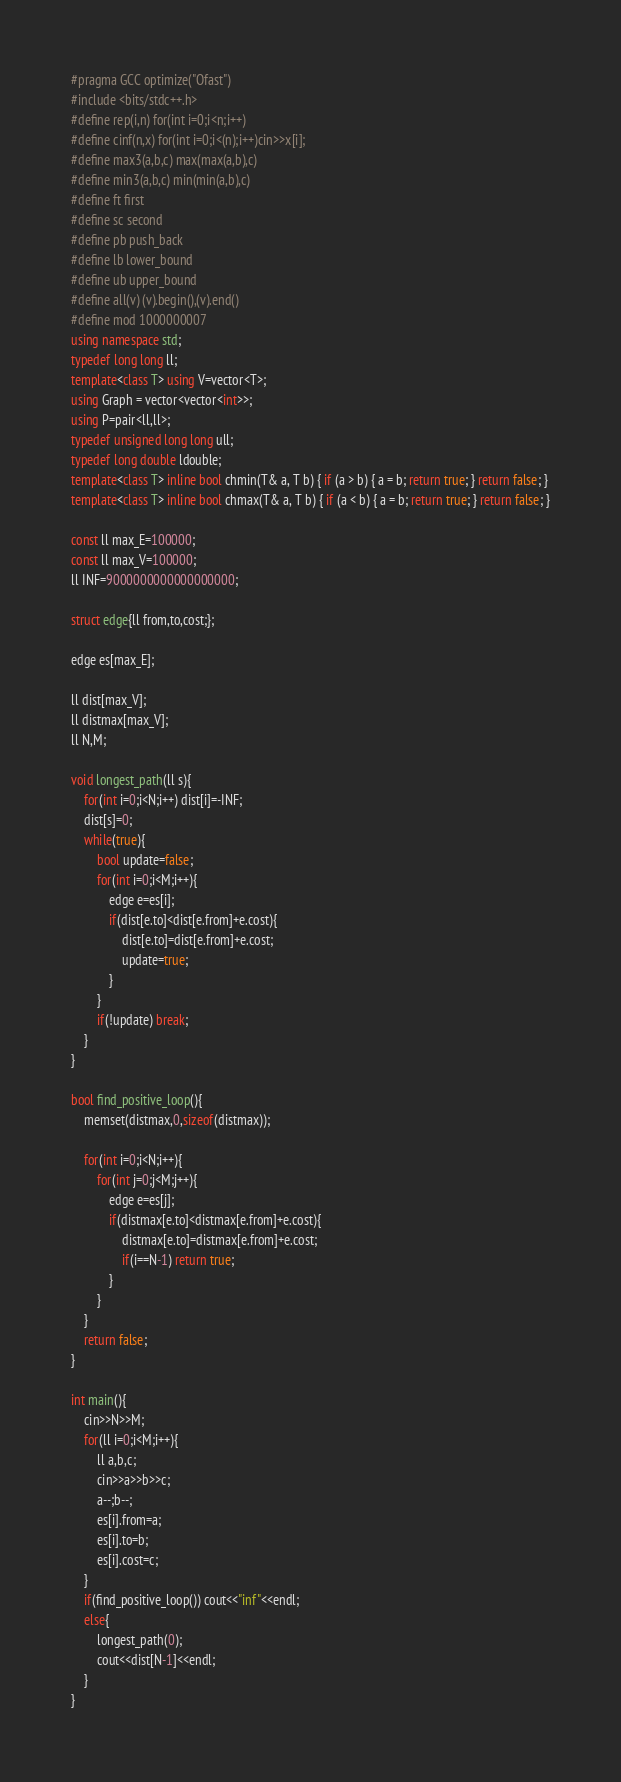<code> <loc_0><loc_0><loc_500><loc_500><_C++_>#pragma GCC optimize("Ofast")
#include <bits/stdc++.h>
#define rep(i,n) for(int i=0;i<n;i++)
#define cinf(n,x) for(int i=0;i<(n);i++)cin>>x[i];
#define max3(a,b,c) max(max(a,b),c)
#define min3(a,b,c) min(min(a,b),c)
#define ft first
#define sc second
#define pb push_back
#define lb lower_bound
#define ub upper_bound
#define all(v) (v).begin(),(v).end()
#define mod 1000000007
using namespace std;
typedef long long ll;
template<class T> using V=vector<T>;
using Graph = vector<vector<int>>;
using P=pair<ll,ll>;
typedef unsigned long long ull;
typedef long double ldouble;
template<class T> inline bool chmin(T& a, T b) { if (a > b) { a = b; return true; } return false; }
template<class T> inline bool chmax(T& a, T b) { if (a < b) { a = b; return true; } return false; }

const ll max_E=100000;
const ll max_V=100000;
ll INF=9000000000000000000;

struct edge{ll from,to,cost;};

edge es[max_E];

ll dist[max_V];
ll distmax[max_V];
ll N,M;

void longest_path(ll s){
    for(int i=0;i<N;i++) dist[i]=-INF;
    dist[s]=0;
    while(true){
        bool update=false;
        for(int i=0;i<M;i++){
            edge e=es[i];
            if(dist[e.to]<dist[e.from]+e.cost){
                dist[e.to]=dist[e.from]+e.cost;
                update=true;
            }
        }
        if(!update) break;
    }
}

bool find_positive_loop(){
    memset(distmax,0,sizeof(distmax));
    
    for(int i=0;i<N;i++){
        for(int j=0;j<M;j++){
            edge e=es[j];
            if(distmax[e.to]<distmax[e.from]+e.cost){
                distmax[e.to]=distmax[e.from]+e.cost;
                if(i==N-1) return true;
            }
        }
    }
    return false;
}

int main(){
    cin>>N>>M;
    for(ll i=0;i<M;i++){
        ll a,b,c;
        cin>>a>>b>>c;
        a--;b--;
        es[i].from=a;
        es[i].to=b;
        es[i].cost=c;
    }
    if(find_positive_loop()) cout<<"inf"<<endl;
    else{
        longest_path(0);
        cout<<dist[N-1]<<endl;
    }
}</code> 